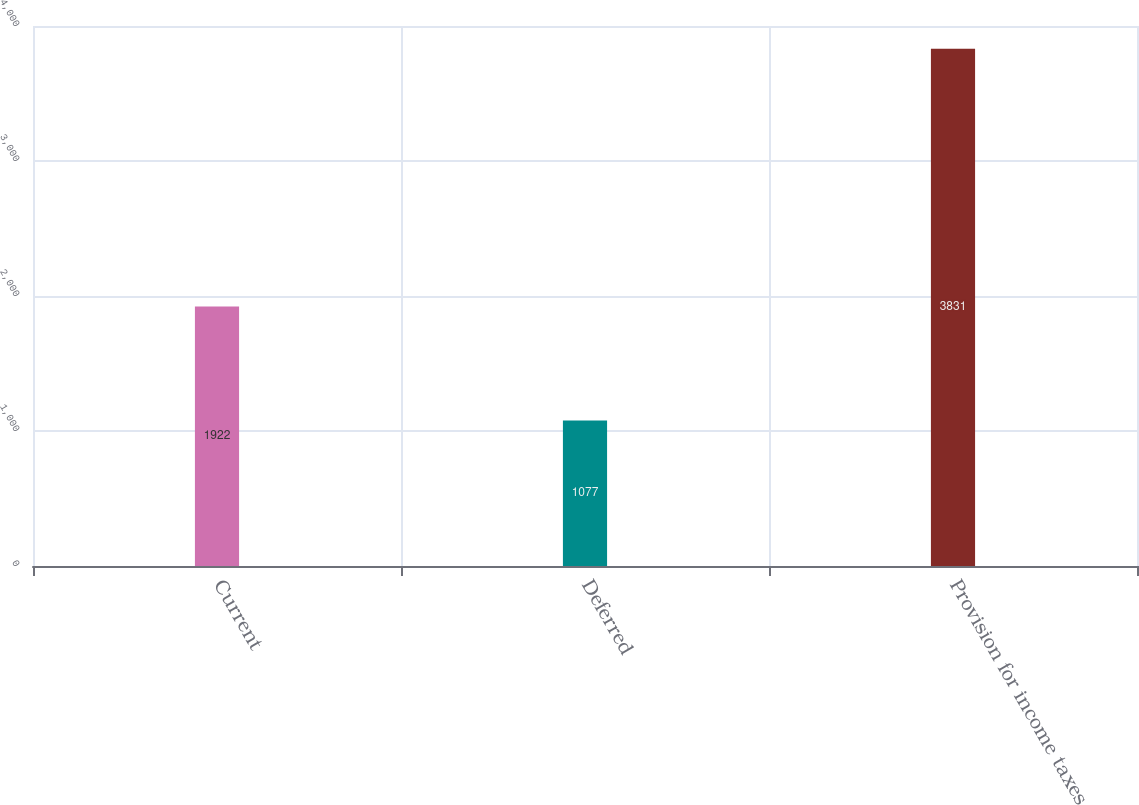Convert chart to OTSL. <chart><loc_0><loc_0><loc_500><loc_500><bar_chart><fcel>Current<fcel>Deferred<fcel>Provision for income taxes<nl><fcel>1922<fcel>1077<fcel>3831<nl></chart> 